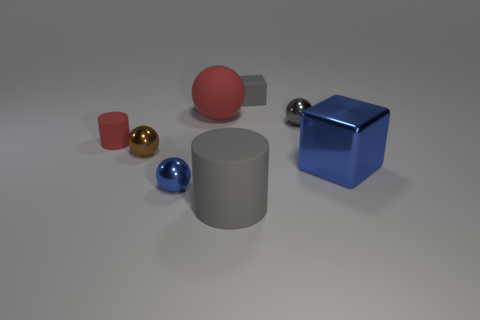Add 1 big metal things. How many objects exist? 9 Subtract all tiny brown metal balls. How many balls are left? 3 Subtract all blocks. How many objects are left? 6 Subtract all brown spheres. How many spheres are left? 3 Subtract 1 spheres. How many spheres are left? 3 Add 2 big red spheres. How many big red spheres exist? 3 Subtract 0 yellow cylinders. How many objects are left? 8 Subtract all gray balls. Subtract all purple blocks. How many balls are left? 3 Subtract all blue metallic blocks. Subtract all large yellow spheres. How many objects are left? 7 Add 3 gray matte cylinders. How many gray matte cylinders are left? 4 